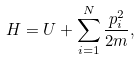Convert formula to latex. <formula><loc_0><loc_0><loc_500><loc_500>H = U + \sum _ { i = 1 } ^ { N } \frac { p _ { i } ^ { 2 } } { 2 m } ,</formula> 